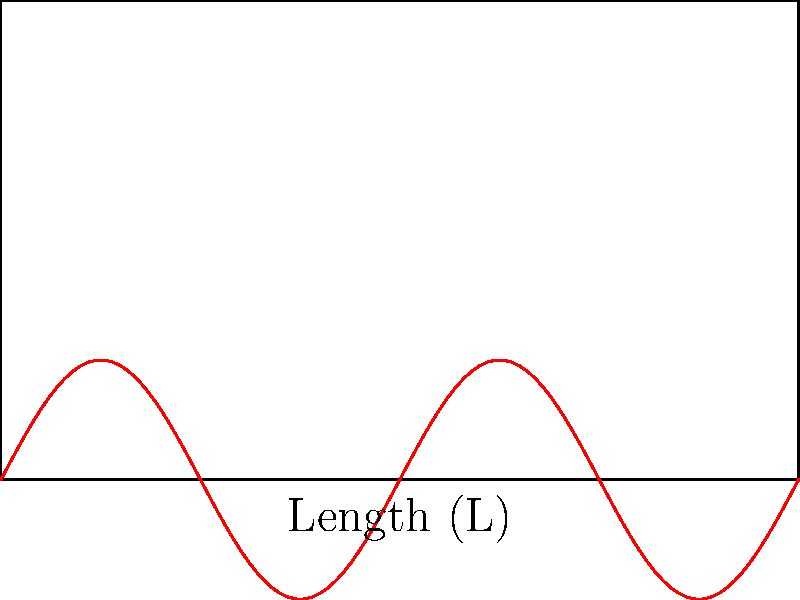In a rectangular concert hall with dimensions 10m x 6m, as shown in the diagram, a mariachi band is performing. If the fundamental frequency of the acoustic wave propagating along the length of the hall is 17 Hz, what is the speed of sound in the hall? Assume the temperature and humidity conditions in the hall are such that they don't significantly affect the speed of sound from its typical value in air. To solve this problem, we'll follow these steps:

1) Recall the relationship between wavelength ($\lambda$), frequency ($f$), and wave speed ($v$):

   $$v = \lambda f$$

2) For a rectangular enclosure, the fundamental wavelength along the length is twice the length of the enclosure. In this case:

   $$\lambda = 2L = 2 \cdot 10\text{m} = 20\text{m}$$

3) We're given the fundamental frequency:

   $$f = 17\text{Hz}$$

4) Now, we can substitute these values into the wave speed equation:

   $$v = \lambda f = 20\text{m} \cdot 17\text{Hz} = 340\text{m/s}$$

5) This result aligns with the typical speed of sound in air at room temperature (approximately 343 m/s), which validates our calculation.
Answer: 340 m/s 